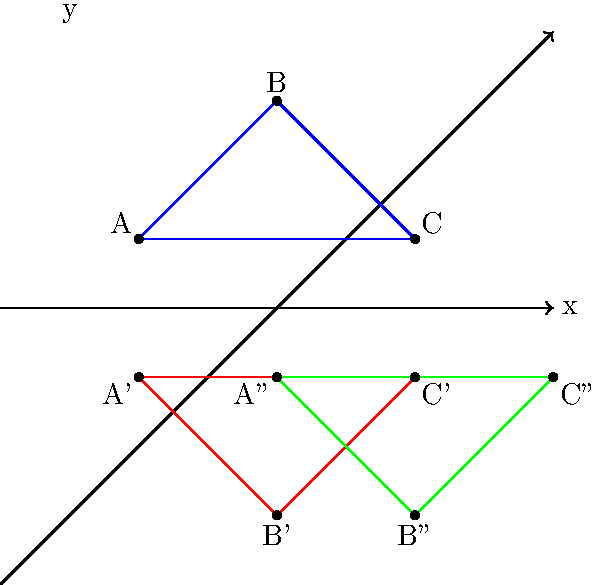Consider triangle ABC on the coordinate plane. If triangle A'B'C' is the result of reflecting triangle ABC across the x-axis, and triangle A''B''C'' is the result of translating triangle A'B'C' 2 units to the right, what single transformation would directly map triangle ABC to triangle A''B''C''? Let's approach this step-by-step:

1) First, we need to understand the two transformations applied:
   a) Reflection of ABC across the x-axis to get A'B'C'
   b) Translation of A'B'C' 2 units right to get A''B''C''

2) For a reflection across the x-axis:
   - The x-coordinates remain the same
   - The y-coordinates change sign (positive becomes negative and vice versa)

3) For a translation 2 units to the right:
   - 2 is added to each x-coordinate
   - The y-coordinates remain the same

4) If we combine these transformations:
   - The x-coordinates increase by 2
   - The y-coordinates change sign

5) This combination of changes can be achieved by a single transformation: a glide reflection.

6) A glide reflection is a composition of a reflection and a translation parallel to the line of reflection.

7) In this case:
   - The reflection is across the x-axis
   - The translation is 2 units to the right, which is parallel to the x-axis

Therefore, the single transformation that would directly map triangle ABC to triangle A''B''C'' is a glide reflection across the x-axis with a translation of 2 units to the right.
Answer: Glide reflection across the x-axis with a translation of 2 units right 